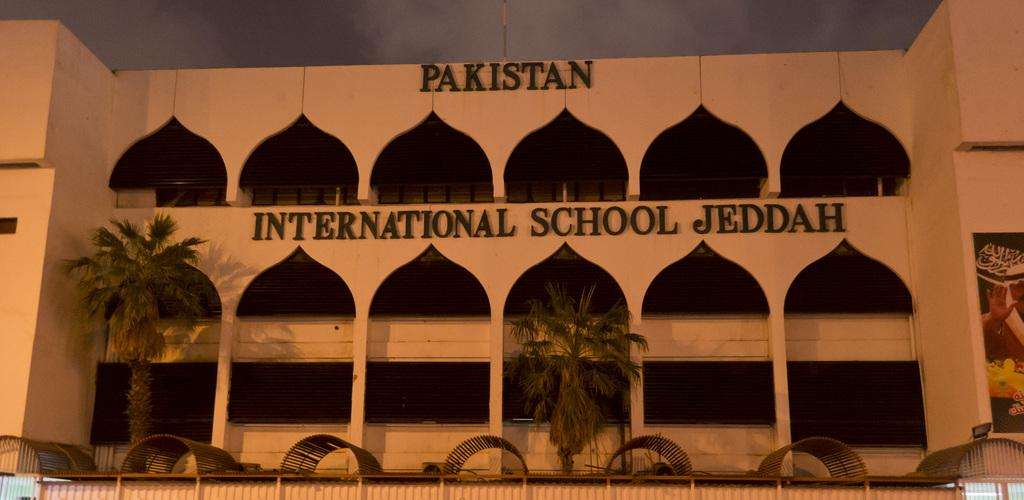What is the main subject in the center of the image? There is a building and trees in the center of the image. What can be seen in the background of the image? The sky is visible in the background of the image. Are there any weather conditions depicted in the image? Yes, clouds are present in the background of the image. What type of finger can be seen pointing at the building in the image? There is no finger present in the image, let alone pointing at the building. 